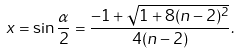<formula> <loc_0><loc_0><loc_500><loc_500>x = \sin \frac { \alpha } { 2 } = \frac { - 1 + \sqrt { 1 + 8 ( n - 2 ) ^ { 2 } } } { 4 ( n - 2 ) } .</formula> 